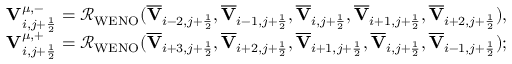<formula> <loc_0><loc_0><loc_500><loc_500>\begin{array} { r } { { V } _ { i , j + \frac { 1 } { 2 } } ^ { \mu , - } = \mathcal { R } _ { W E N O } ( \overline { V } _ { i - 2 , j + \frac { 1 } { 2 } } , \overline { V } _ { i - 1 , j + \frac { 1 } { 2 } } , \overline { V } _ { i , j + \frac { 1 } { 2 } } , \overline { V } _ { i + 1 , j + \frac { 1 } { 2 } } , \overline { V } _ { i + 2 , j + \frac { 1 } { 2 } } ) , } \\ { { V } _ { i , j + \frac { 1 } { 2 } } ^ { \mu , + } = \mathcal { R } _ { W E N O } ( \overline { V } _ { i + 3 , j + \frac { 1 } { 2 } } , \overline { V } _ { i + 2 , j + \frac { 1 } { 2 } } , \overline { V } _ { i + 1 , j + \frac { 1 } { 2 } } , \overline { V } _ { i , j + \frac { 1 } { 2 } } , \overline { V } _ { i - 1 , j + \frac { 1 } { 2 } } ) ; } \end{array}</formula> 